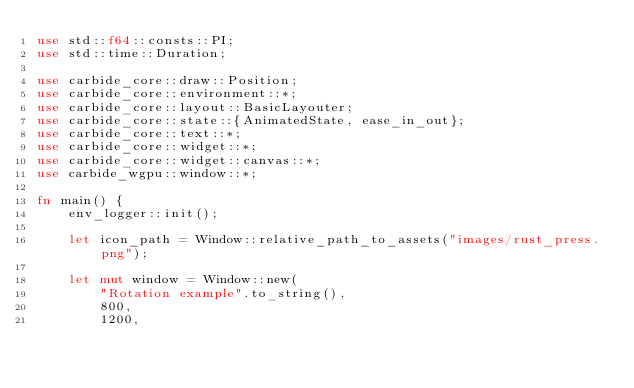<code> <loc_0><loc_0><loc_500><loc_500><_Rust_>use std::f64::consts::PI;
use std::time::Duration;

use carbide_core::draw::Position;
use carbide_core::environment::*;
use carbide_core::layout::BasicLayouter;
use carbide_core::state::{AnimatedState, ease_in_out};
use carbide_core::text::*;
use carbide_core::widget::*;
use carbide_core::widget::canvas::*;
use carbide_wgpu::window::*;

fn main() {
    env_logger::init();

    let icon_path = Window::relative_path_to_assets("images/rust_press.png");

    let mut window = Window::new(
        "Rotation example".to_string(),
        800,
        1200,</code> 